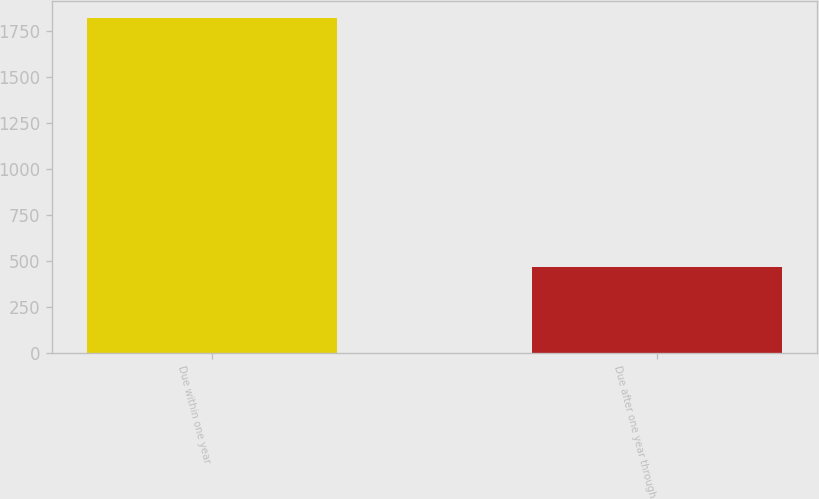Convert chart. <chart><loc_0><loc_0><loc_500><loc_500><bar_chart><fcel>Due within one year<fcel>Due after one year through<nl><fcel>1818<fcel>466<nl></chart> 